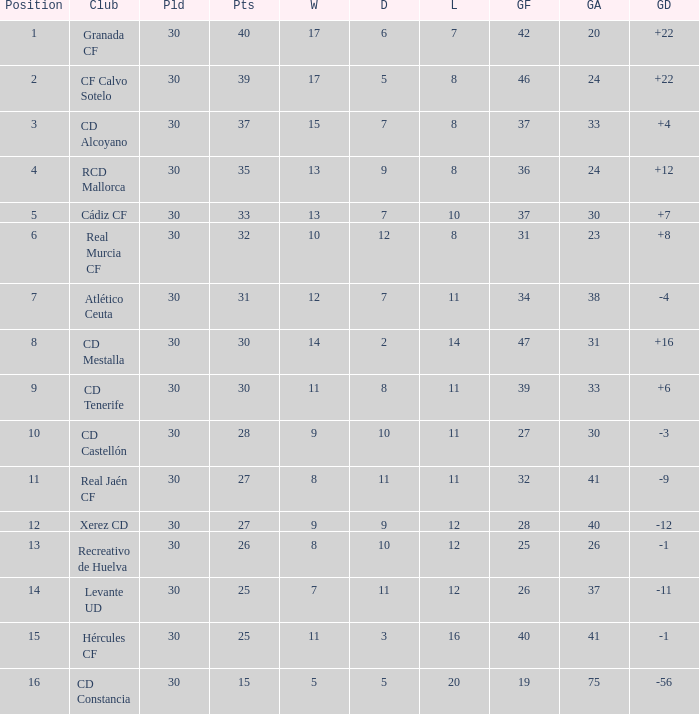How many Wins have Goals against smaller than 30, and Goals for larger than 25, and Draws larger than 5? 3.0. 